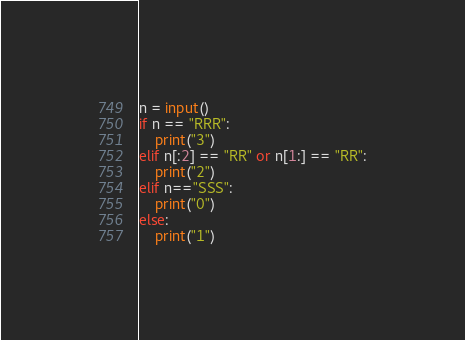<code> <loc_0><loc_0><loc_500><loc_500><_Python_>n = input()
if n == "RRR":
    print("3")
elif n[:2] == "RR" or n[1:] == "RR":
    print("2")
elif n=="SSS":
    print("0")
else:
    print("1")</code> 